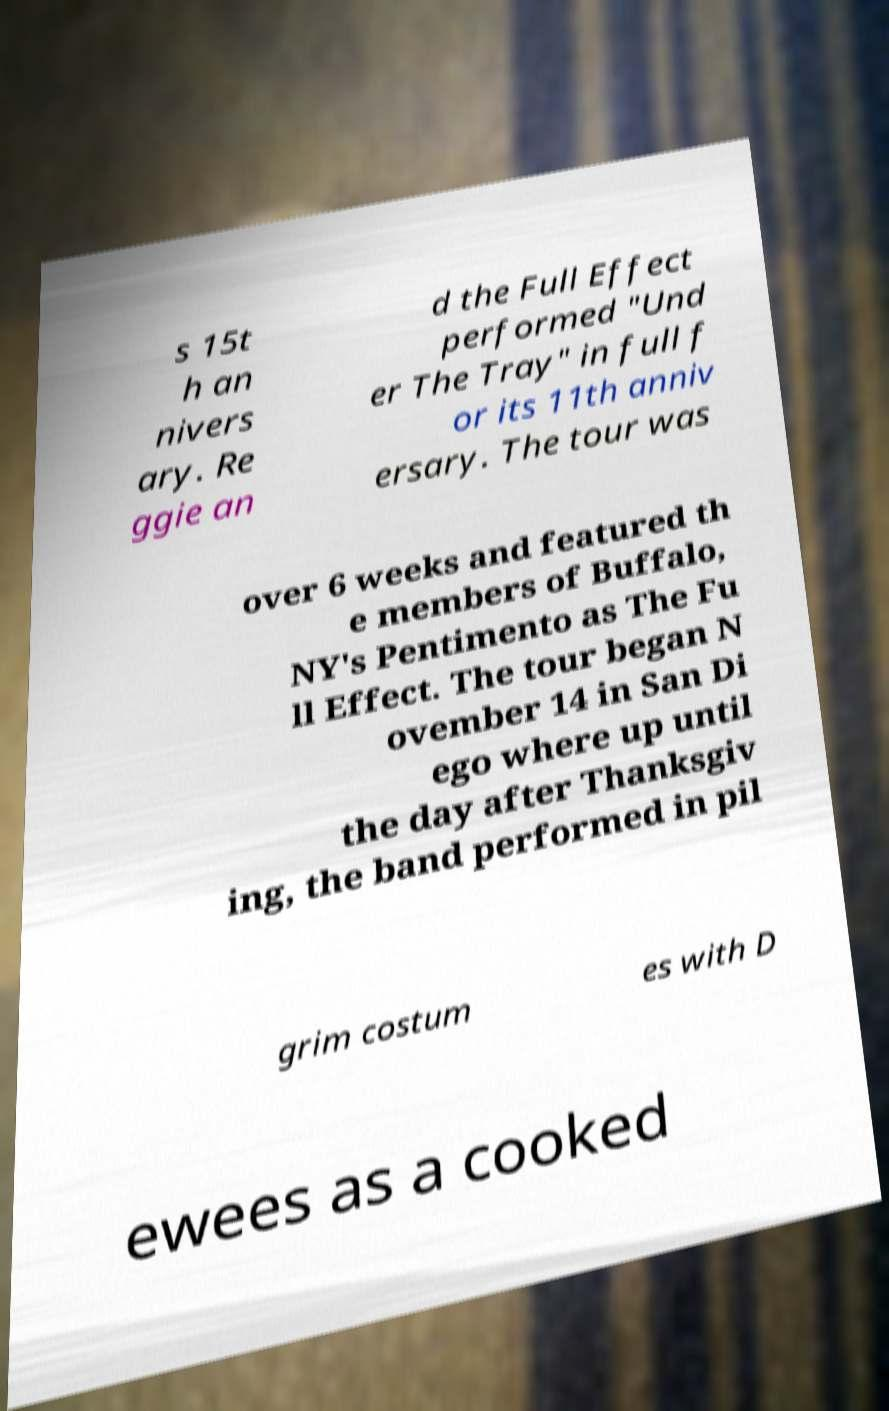Could you extract and type out the text from this image? s 15t h an nivers ary. Re ggie an d the Full Effect performed "Und er The Tray" in full f or its 11th anniv ersary. The tour was over 6 weeks and featured th e members of Buffalo, NY's Pentimento as The Fu ll Effect. The tour began N ovember 14 in San Di ego where up until the day after Thanksgiv ing, the band performed in pil grim costum es with D ewees as a cooked 